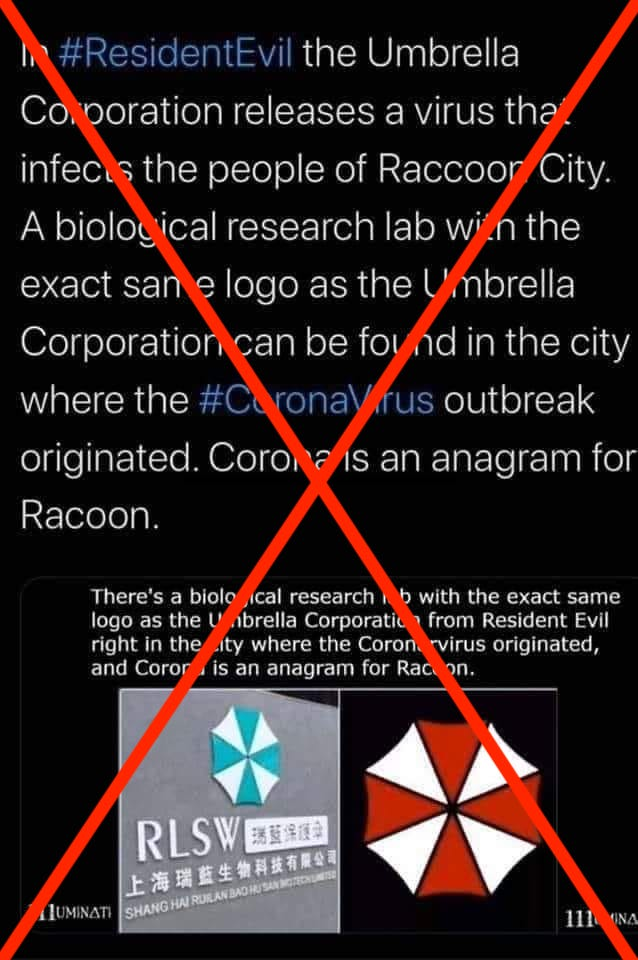Can you explain how misinformation about health issues can affect public behavior? Misinformation about health, such as the false connection between a video game and a real virus outbreak, can have serious consequences for public behavior. It can lead to unwarranted fear and panic, promote stigma against certain groups or places, and result in people disregarding advice from actual health authorities. This can hamper public health responses, lead individuals to seek out unproven or dangerous 'cures,' and ultimately undermine the collective effort needed to manage and contain health crises effectively. It's crucial for public health communication to be clear, transparent, and evidence-based to foster trust and adherence to recommended health practices. 